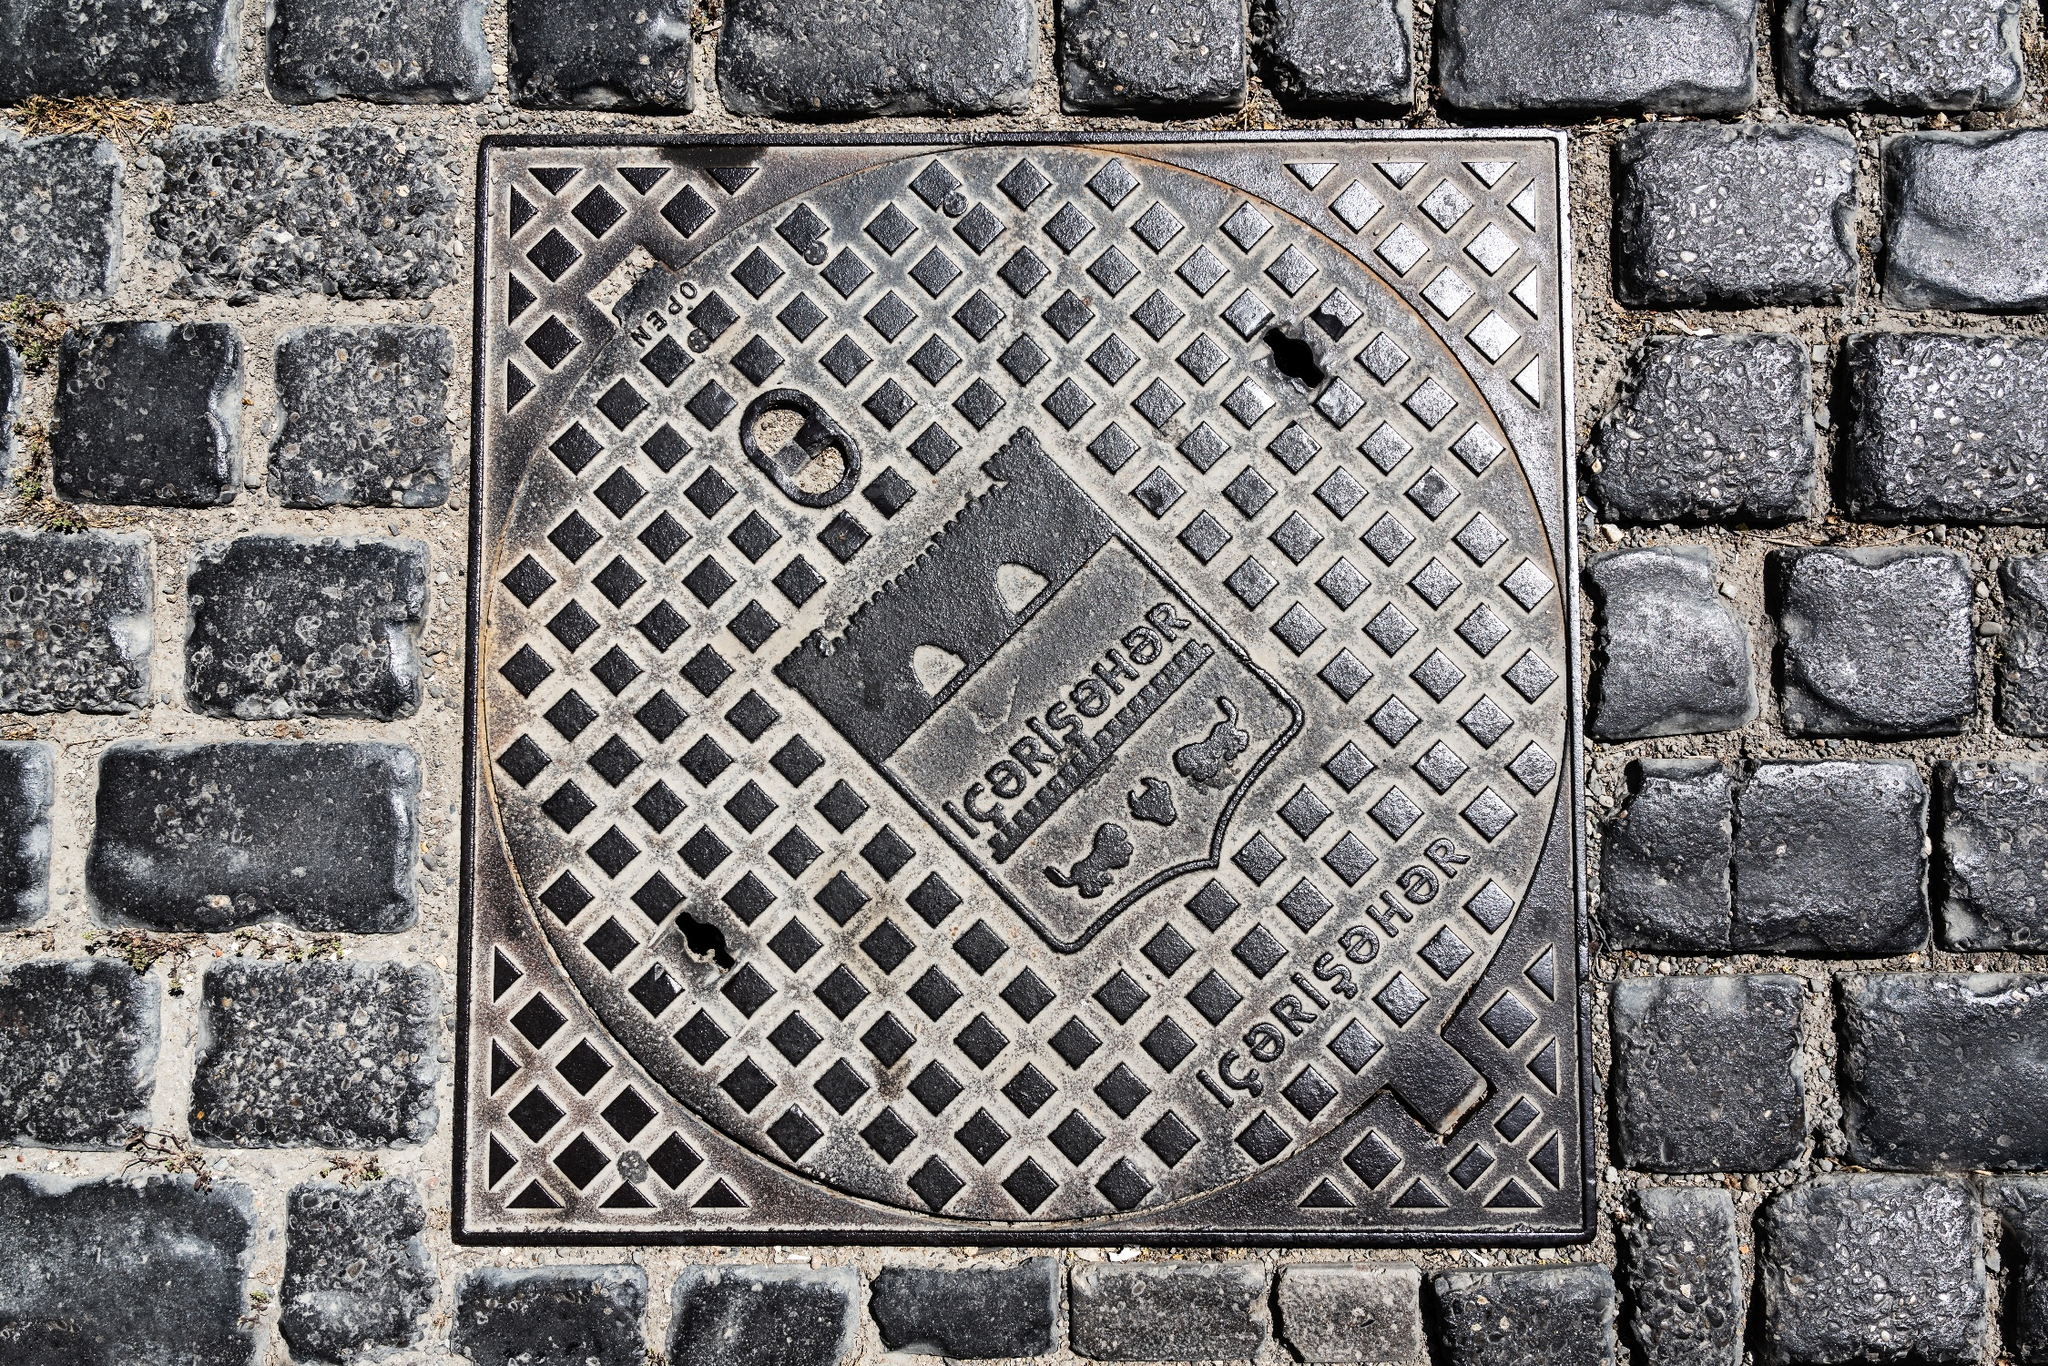Describe the following image. Before you lies an old manhole cover, a testament to craftsmanship with its detailed geometric lattice design, embedded within a weathered cobblestone street. The manhole cover is emblazoned with the inscription 'GORENJE' twice over, possibly signifying the brand or origin of the piece. Its dark metal surface reveals the rich patina of age and use, punctuated by specks of rust clinging to its surface, bearing witness to countless seasons. The cobblestones cradle the manhole cover, offering a contrast in texture and color, while spots of green moss accentuate the intersection of human-made and natural elements on this historical city canvas. 